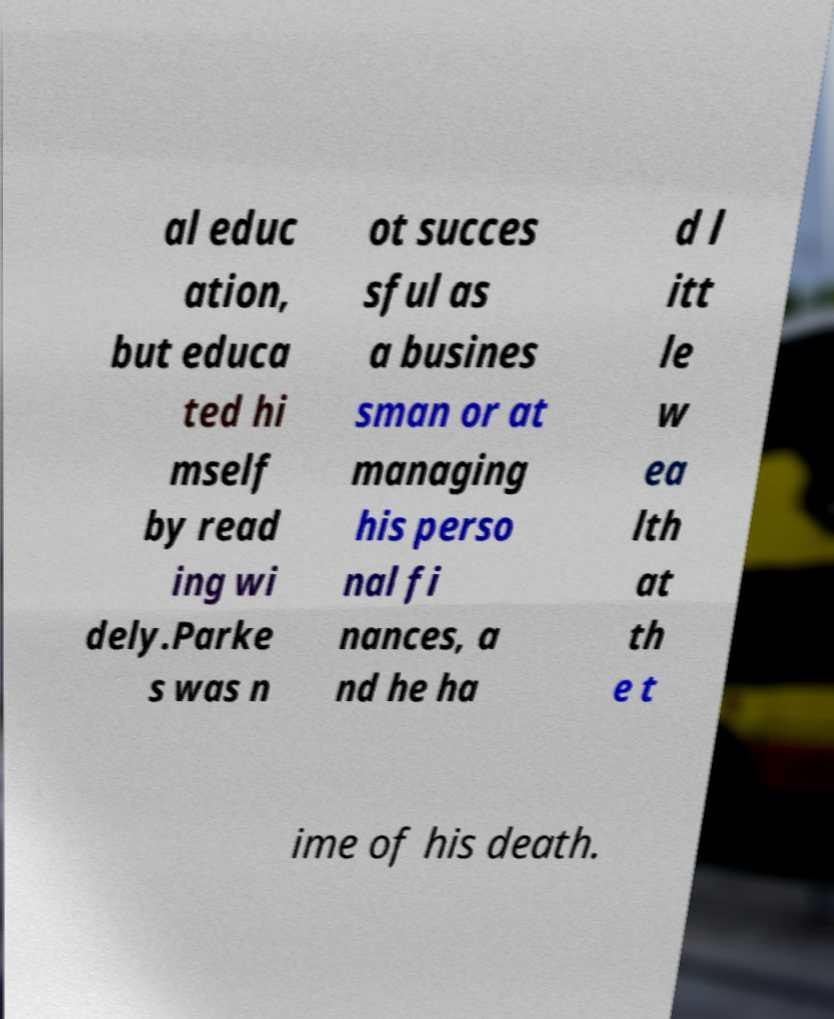Can you read and provide the text displayed in the image?This photo seems to have some interesting text. Can you extract and type it out for me? al educ ation, but educa ted hi mself by read ing wi dely.Parke s was n ot succes sful as a busines sman or at managing his perso nal fi nances, a nd he ha d l itt le w ea lth at th e t ime of his death. 